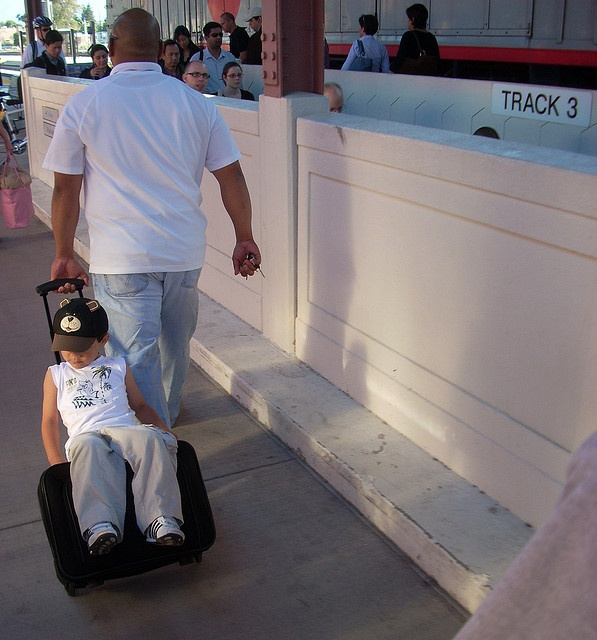Describe the objects in this image and their specific colors. I can see people in white, darkgray, gray, and maroon tones, people in white, gray, darkgray, black, and lightgray tones, suitcase in white, black, gray, and darkgray tones, people in white, black, gray, and maroon tones, and people in white, black, purple, and maroon tones in this image. 